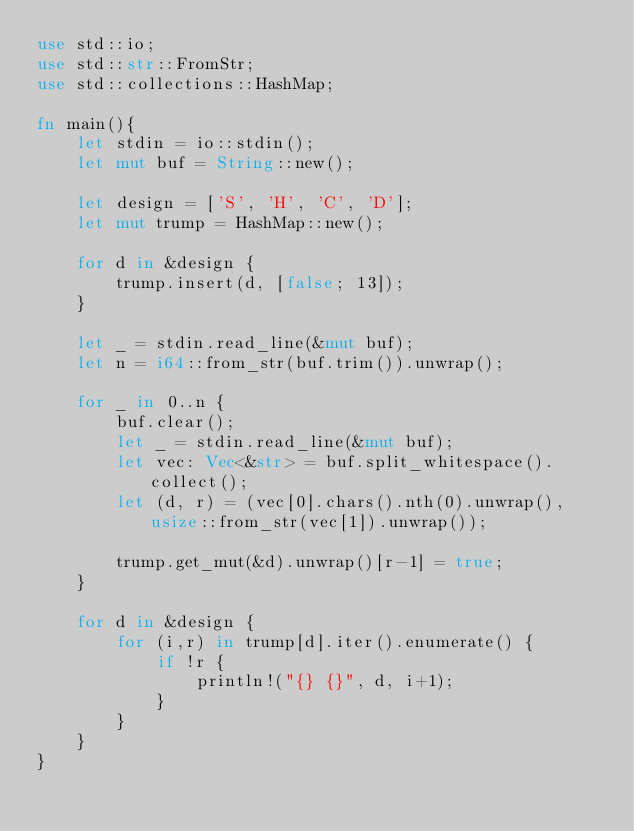Convert code to text. <code><loc_0><loc_0><loc_500><loc_500><_Rust_>use std::io;
use std::str::FromStr;
use std::collections::HashMap;

fn main(){
    let stdin = io::stdin();
    let mut buf = String::new();

    let design = ['S', 'H', 'C', 'D'];
    let mut trump = HashMap::new();

    for d in &design {
        trump.insert(d, [false; 13]);
    }

    let _ = stdin.read_line(&mut buf);
    let n = i64::from_str(buf.trim()).unwrap();

    for _ in 0..n {
        buf.clear();
        let _ = stdin.read_line(&mut buf);
        let vec: Vec<&str> = buf.split_whitespace().collect();
        let (d, r) = (vec[0].chars().nth(0).unwrap(), usize::from_str(vec[1]).unwrap());

        trump.get_mut(&d).unwrap()[r-1] = true;
    }

    for d in &design {
        for (i,r) in trump[d].iter().enumerate() {
            if !r {
                println!("{} {}", d, i+1);
            }
        }
    }
}

</code> 